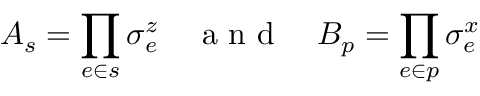Convert formula to latex. <formula><loc_0><loc_0><loc_500><loc_500>A _ { s } = \prod _ { e \in s } \sigma _ { e } ^ { z } \quad a n d \quad B _ { p } = \prod _ { e \in p } \sigma _ { e } ^ { x }</formula> 